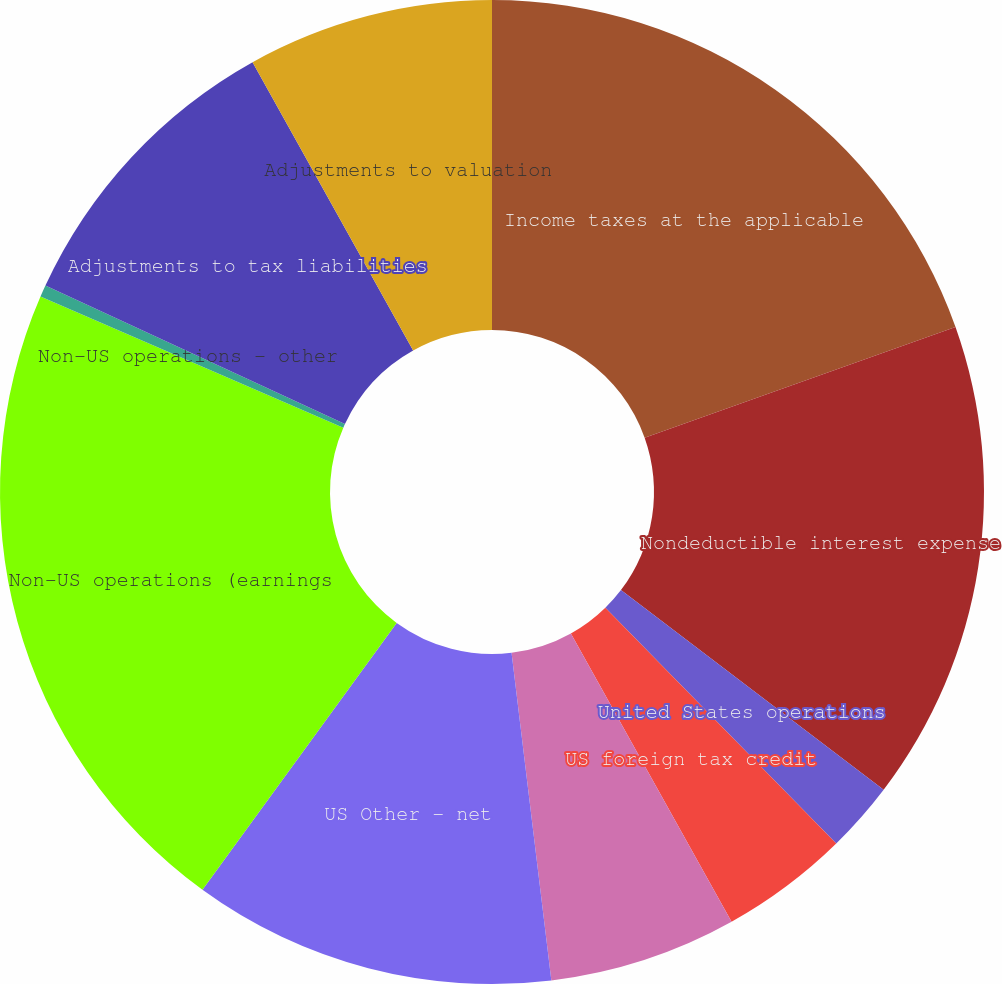Convert chart. <chart><loc_0><loc_0><loc_500><loc_500><pie_chart><fcel>Income taxes at the applicable<fcel>Nondeductible interest expense<fcel>United States operations<fcel>US foreign tax credit<fcel>Credit for research activities<fcel>US Other - net<fcel>Non-US operations (earnings<fcel>Non-US operations - other<fcel>Adjustments to tax liabilities<fcel>Adjustments to valuation<nl><fcel>19.56%<fcel>15.79%<fcel>2.32%<fcel>4.24%<fcel>6.17%<fcel>11.94%<fcel>21.49%<fcel>0.39%<fcel>10.02%<fcel>8.09%<nl></chart> 